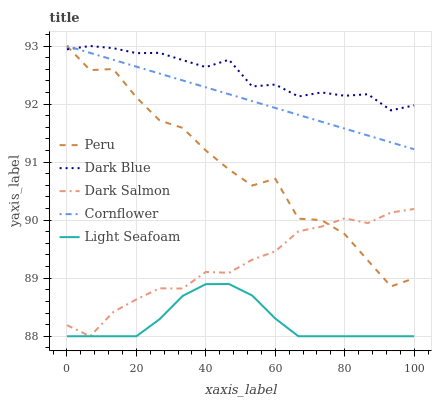Does Light Seafoam have the minimum area under the curve?
Answer yes or no. Yes. Does Dark Blue have the maximum area under the curve?
Answer yes or no. Yes. Does Dark Salmon have the minimum area under the curve?
Answer yes or no. No. Does Dark Salmon have the maximum area under the curve?
Answer yes or no. No. Is Cornflower the smoothest?
Answer yes or no. Yes. Is Peru the roughest?
Answer yes or no. Yes. Is Light Seafoam the smoothest?
Answer yes or no. No. Is Light Seafoam the roughest?
Answer yes or no. No. Does Light Seafoam have the lowest value?
Answer yes or no. Yes. Does Peru have the lowest value?
Answer yes or no. No. Does Cornflower have the highest value?
Answer yes or no. Yes. Does Dark Salmon have the highest value?
Answer yes or no. No. Is Light Seafoam less than Peru?
Answer yes or no. Yes. Is Cornflower greater than Dark Salmon?
Answer yes or no. Yes. Does Peru intersect Dark Blue?
Answer yes or no. Yes. Is Peru less than Dark Blue?
Answer yes or no. No. Is Peru greater than Dark Blue?
Answer yes or no. No. Does Light Seafoam intersect Peru?
Answer yes or no. No. 